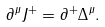Convert formula to latex. <formula><loc_0><loc_0><loc_500><loc_500>\partial ^ { \mu } J ^ { + } = \partial ^ { + } \Delta ^ { \mu } .</formula> 